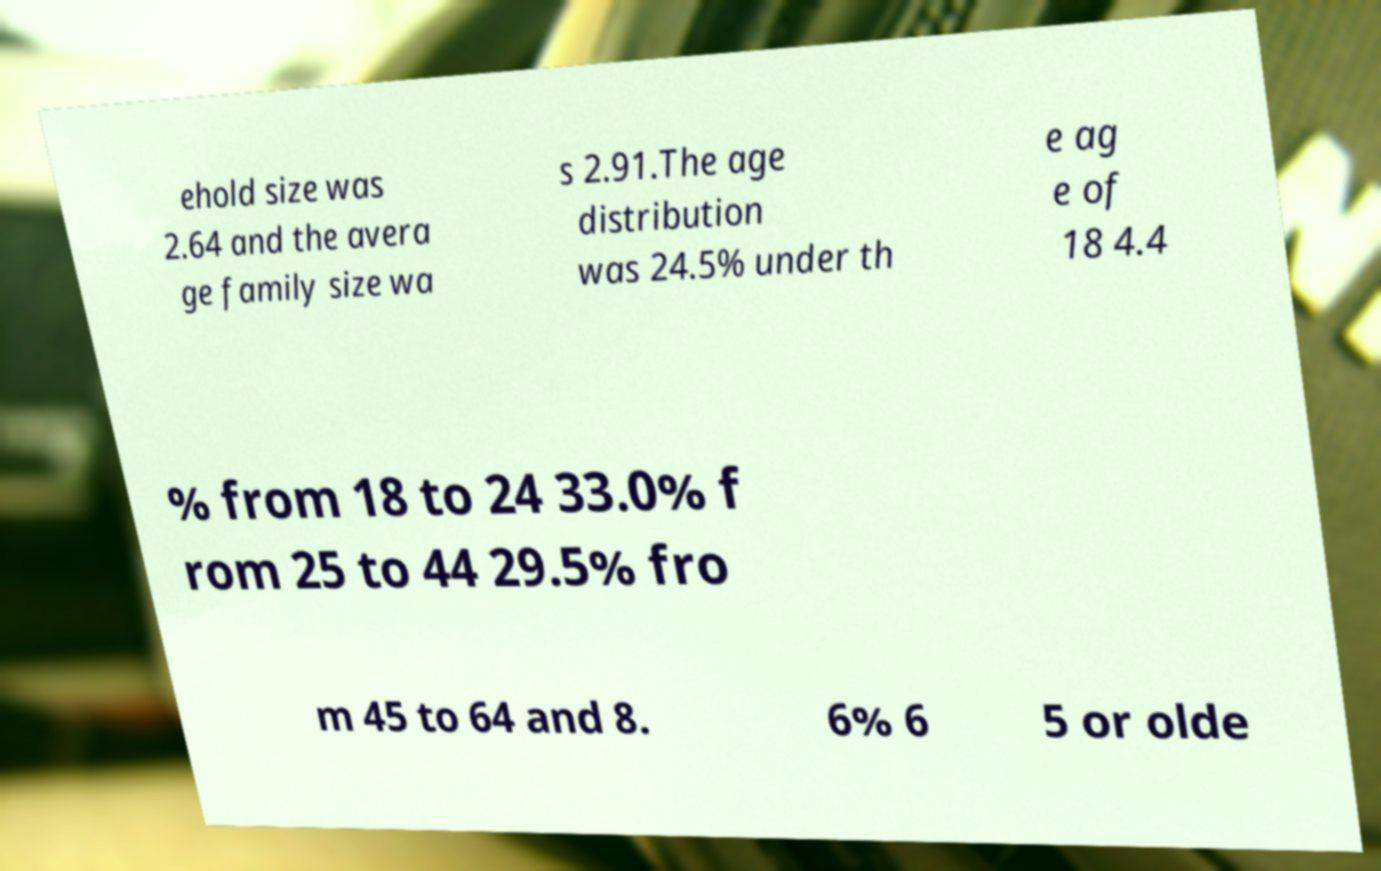I need the written content from this picture converted into text. Can you do that? ehold size was 2.64 and the avera ge family size wa s 2.91.The age distribution was 24.5% under th e ag e of 18 4.4 % from 18 to 24 33.0% f rom 25 to 44 29.5% fro m 45 to 64 and 8. 6% 6 5 or olde 